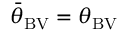<formula> <loc_0><loc_0><loc_500><loc_500>{ \bar { \theta } } _ { B V } = \theta _ { B V }</formula> 